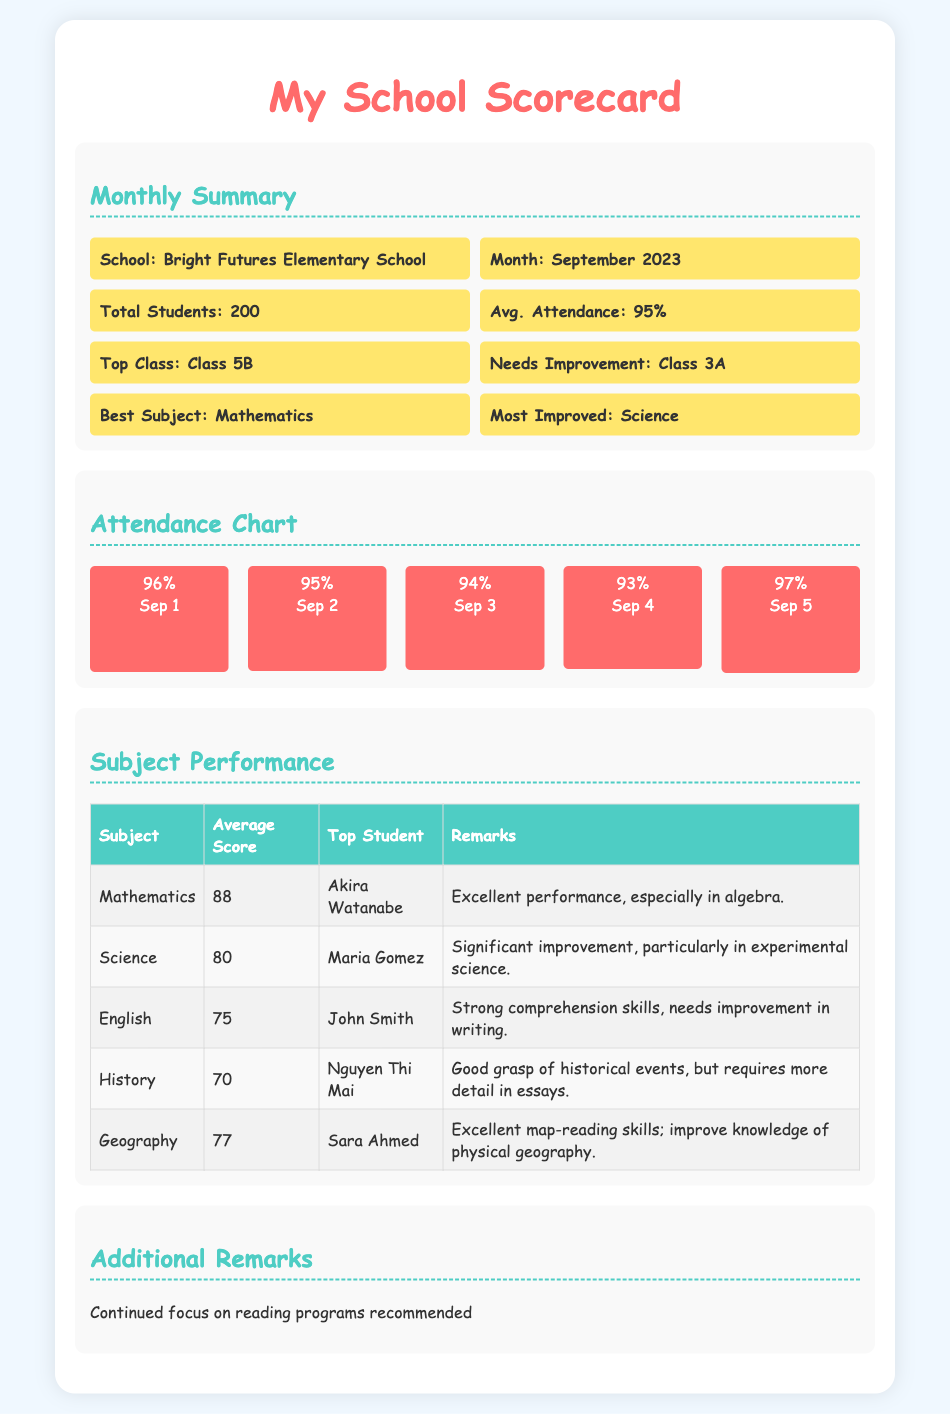What is the school name? The school name is mentioned in the Monthly Summary section.
Answer: Bright Futures Elementary School What was the average attendance percentage? The average attendance is provided in the Monthly Summary section.
Answer: 95% Who was the top student in Mathematics? The top student in Mathematics is mentioned in the Subject Performance table.
Answer: Akira Watanabe Which subject showed significant improvement this month? The subject that showed improvement is noted in the Monthly Summary section as well as the Subject Performance table.
Answer: Science What was the average score in English? The average score in English is included in the Subject Performance table.
Answer: 75 What is the class that needs improvement? The class needing improvement is identified in the Monthly Summary section.
Answer: Class 3A What was the best subject this month? The best subject is indicated in the Monthly Summary section.
Answer: Mathematics How many total students are in the school? The total number of students is found in the Monthly Summary section.
Answer: 200 What is the performance remark for History? The performance remark is detailed in the Subject Performance table under History.
Answer: Good grasp of historical events, but requires more detail in essays 